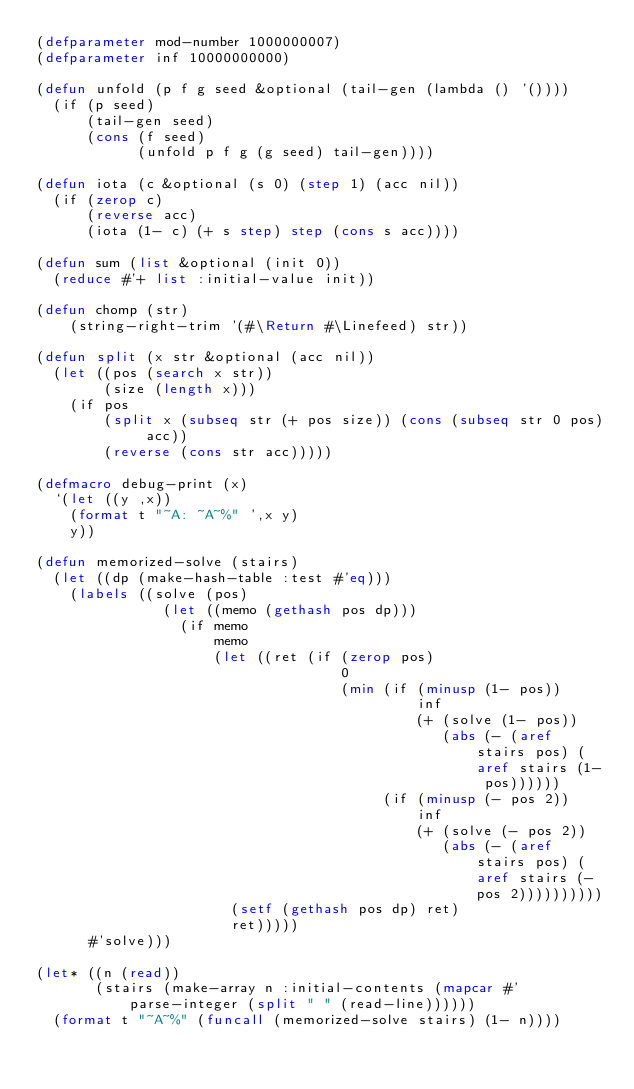<code> <loc_0><loc_0><loc_500><loc_500><_Lisp_>(defparameter mod-number 1000000007)
(defparameter inf 10000000000)

(defun unfold (p f g seed &optional (tail-gen (lambda () '())))
  (if (p seed)
      (tail-gen seed)
	  (cons (f seed)
	        (unfold p f g (g seed) tail-gen))))
  
(defun iota (c &optional (s 0) (step 1) (acc nil))
  (if (zerop c)
      (reverse acc)
      (iota (1- c) (+ s step) step (cons s acc))))
 
(defun sum (list &optional (init 0))
  (reduce #'+ list :initial-value init))
 
(defun chomp (str)
    (string-right-trim '(#\Return #\Linefeed) str))

(defun split (x str &optional (acc nil))
  (let ((pos (search x str))
        (size (length x)))
    (if pos
        (split x (subseq str (+ pos size)) (cons (subseq str 0 pos) acc))
        (reverse (cons str acc)))))

(defmacro debug-print (x)
  `(let ((y ,x))
    (format t "~A: ~A~%" ',x y)
	y))

(defun memorized-solve (stairs)
  (let ((dp (make-hash-table :test #'eq)))
    (labels ((solve (pos)
               (let ((memo (gethash pos dp)))
                 (if memo
                     memo
                     (let ((ret (if (zerop pos)
                                    0
                                    (min (if (minusp (1- pos))
                                             inf
                                             (+ (solve (1- pos))
                                                (abs (- (aref stairs pos) (aref stairs (1- pos))))))
                                         (if (minusp (- pos 2))
                                             inf
                                             (+ (solve (- pos 2))
                                                (abs (- (aref stairs pos) (aref stairs (- pos 2))))))))))
                       (setf (gethash pos dp) ret)
                       ret)))))
      #'solve)))

(let* ((n (read))
       (stairs (make-array n :initial-contents (mapcar #'parse-integer (split " " (read-line))))))
  (format t "~A~%" (funcall (memorized-solve stairs) (1- n))))
</code> 